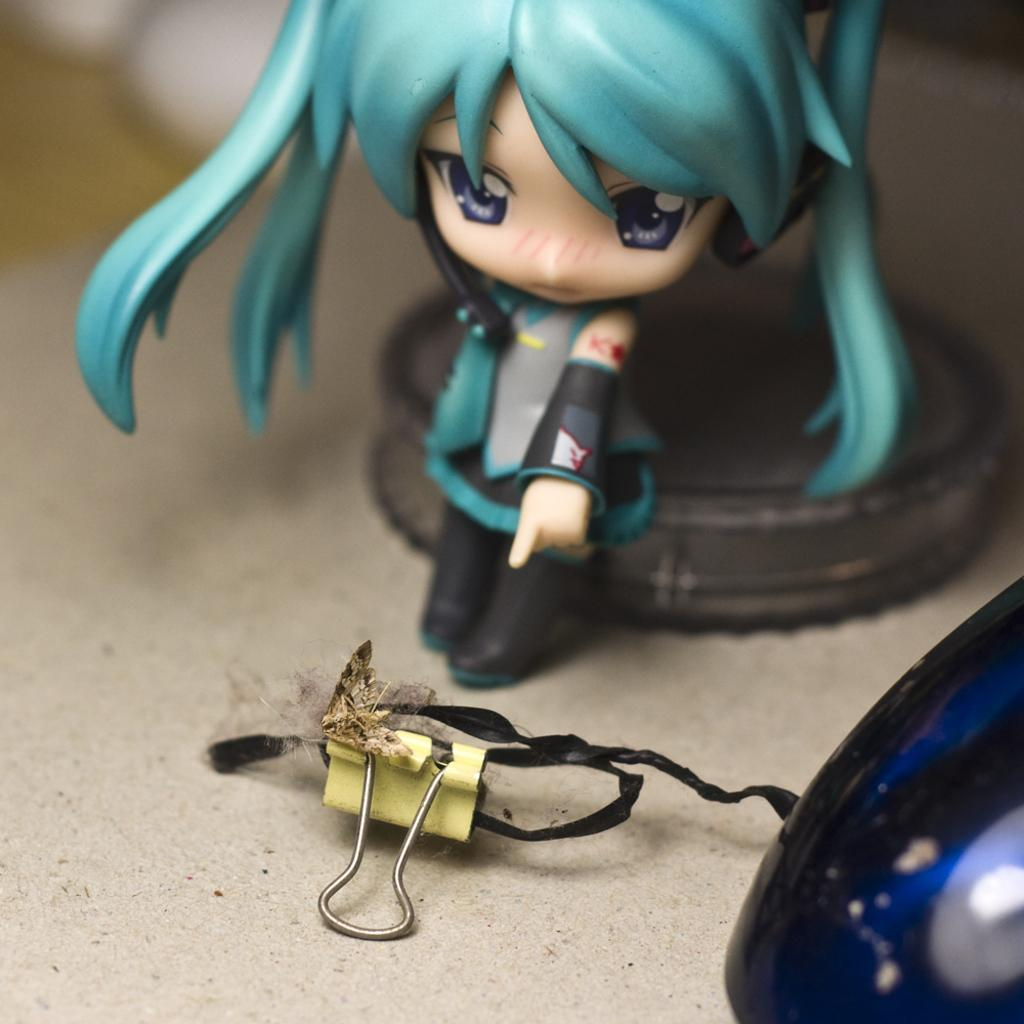What is located at the bottom of the image? There is a table at the bottom of the image. What object can be seen on the table? A clip is present on the table. What other item is on the table? There is a doll on the table. Can you describe the background of the image? The background of the image is blurred. What type of bone is visible on the table in the image? There is no bone present in the image; it features a table with a clip and a doll. 